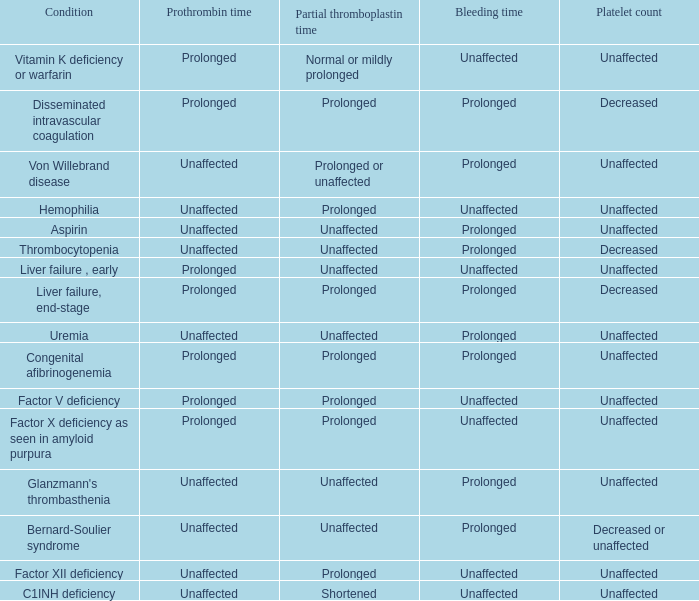Which Platelet count has a Condition of bernard-soulier syndrome? Decreased or unaffected. 